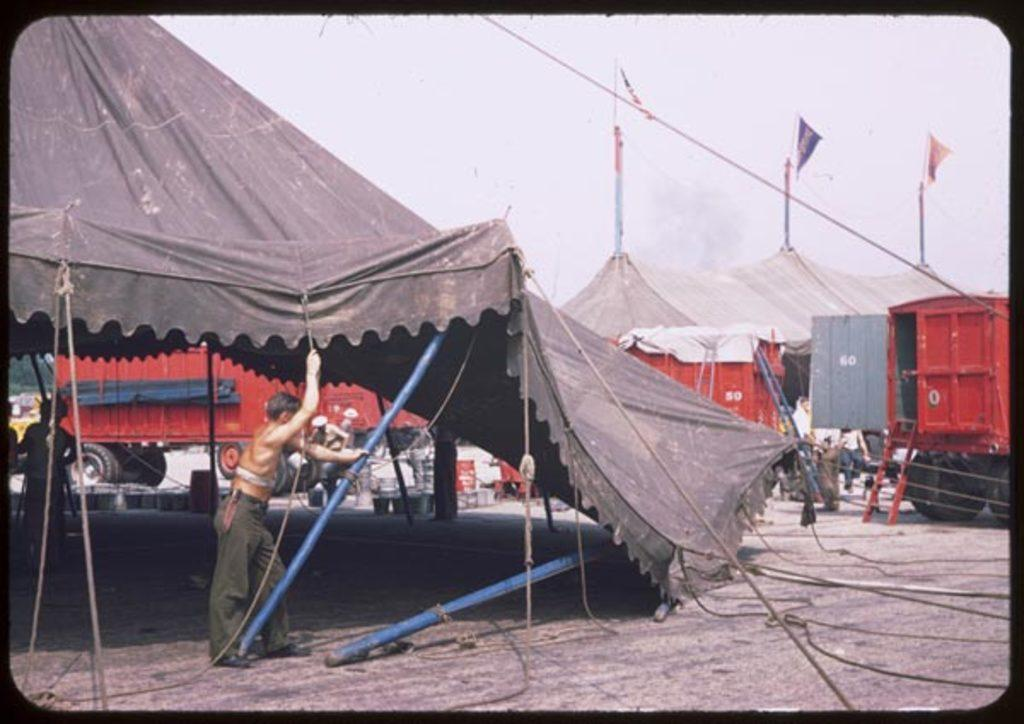What type of temporary shelters can be seen in the image? There are tents in the image. What else is present on the surface in the image? There are vehicles and people on the surface in the image. What can be seen in the sky in the image? Clouds are visible in the sky in the image. Are there any ice sculptures visible in the image? There is no mention of ice sculptures in the provided facts, so we cannot determine if any are present in the image. Are any people wearing masks in the image? There is no mention of masks in the provided facts, so we cannot determine if anyone is wearing a mask in the image. 